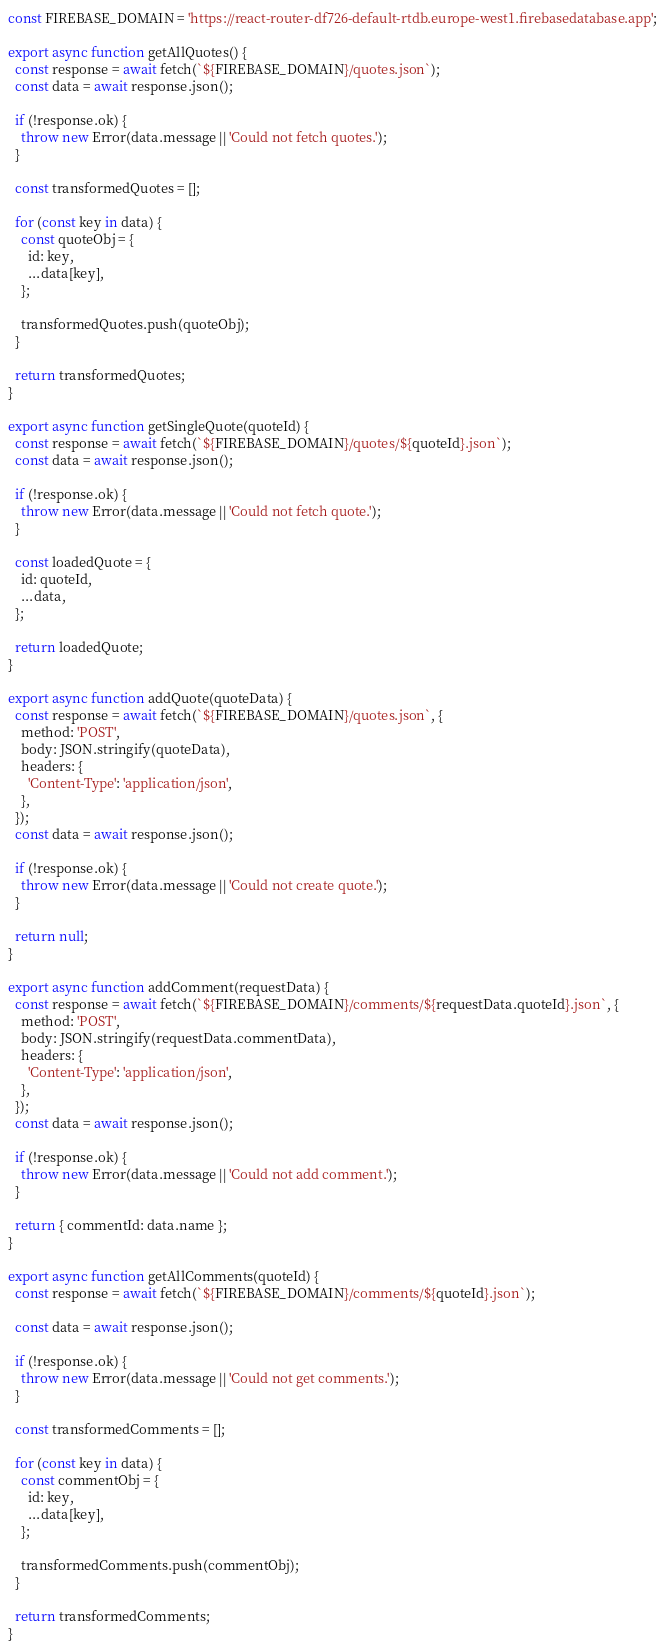<code> <loc_0><loc_0><loc_500><loc_500><_JavaScript_>const FIREBASE_DOMAIN = 'https://react-router-df726-default-rtdb.europe-west1.firebasedatabase.app';

export async function getAllQuotes() {
  const response = await fetch(`${FIREBASE_DOMAIN}/quotes.json`);
  const data = await response.json();

  if (!response.ok) {
    throw new Error(data.message || 'Could not fetch quotes.');
  }

  const transformedQuotes = [];

  for (const key in data) {
    const quoteObj = {
      id: key,
      ...data[key],
    };

    transformedQuotes.push(quoteObj);
  }

  return transformedQuotes;
}

export async function getSingleQuote(quoteId) {
  const response = await fetch(`${FIREBASE_DOMAIN}/quotes/${quoteId}.json`);
  const data = await response.json();

  if (!response.ok) {
    throw new Error(data.message || 'Could not fetch quote.');
  }

  const loadedQuote = {
    id: quoteId,
    ...data,
  };

  return loadedQuote;
}

export async function addQuote(quoteData) {
  const response = await fetch(`${FIREBASE_DOMAIN}/quotes.json`, {
    method: 'POST',
    body: JSON.stringify(quoteData),
    headers: {
      'Content-Type': 'application/json',
    },
  });
  const data = await response.json();

  if (!response.ok) {
    throw new Error(data.message || 'Could not create quote.');
  }

  return null;
}

export async function addComment(requestData) {
  const response = await fetch(`${FIREBASE_DOMAIN}/comments/${requestData.quoteId}.json`, {
    method: 'POST',
    body: JSON.stringify(requestData.commentData),
    headers: {
      'Content-Type': 'application/json',
    },
  });
  const data = await response.json();

  if (!response.ok) {
    throw new Error(data.message || 'Could not add comment.');
  }

  return { commentId: data.name };
}

export async function getAllComments(quoteId) {
  const response = await fetch(`${FIREBASE_DOMAIN}/comments/${quoteId}.json`);

  const data = await response.json();

  if (!response.ok) {
    throw new Error(data.message || 'Could not get comments.');
  }

  const transformedComments = [];

  for (const key in data) {
    const commentObj = {
      id: key,
      ...data[key],
    };

    transformedComments.push(commentObj);
  }

  return transformedComments;
}
</code> 